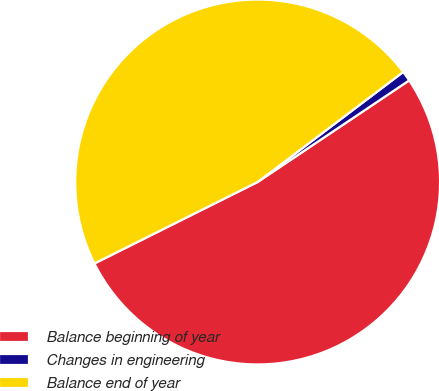Convert chart to OTSL. <chart><loc_0><loc_0><loc_500><loc_500><pie_chart><fcel>Balance beginning of year<fcel>Changes in engineering<fcel>Balance end of year<nl><fcel>52.03%<fcel>0.9%<fcel>47.07%<nl></chart> 